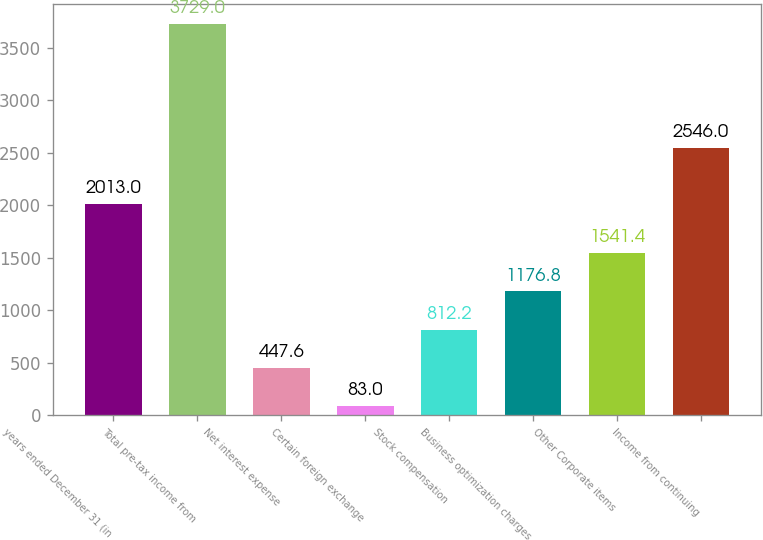<chart> <loc_0><loc_0><loc_500><loc_500><bar_chart><fcel>years ended December 31 (in<fcel>Total pre-tax income from<fcel>Net interest expense<fcel>Certain foreign exchange<fcel>Stock compensation<fcel>Business optimization charges<fcel>Other Corporate items<fcel>Income from continuing<nl><fcel>2013<fcel>3729<fcel>447.6<fcel>83<fcel>812.2<fcel>1176.8<fcel>1541.4<fcel>2546<nl></chart> 